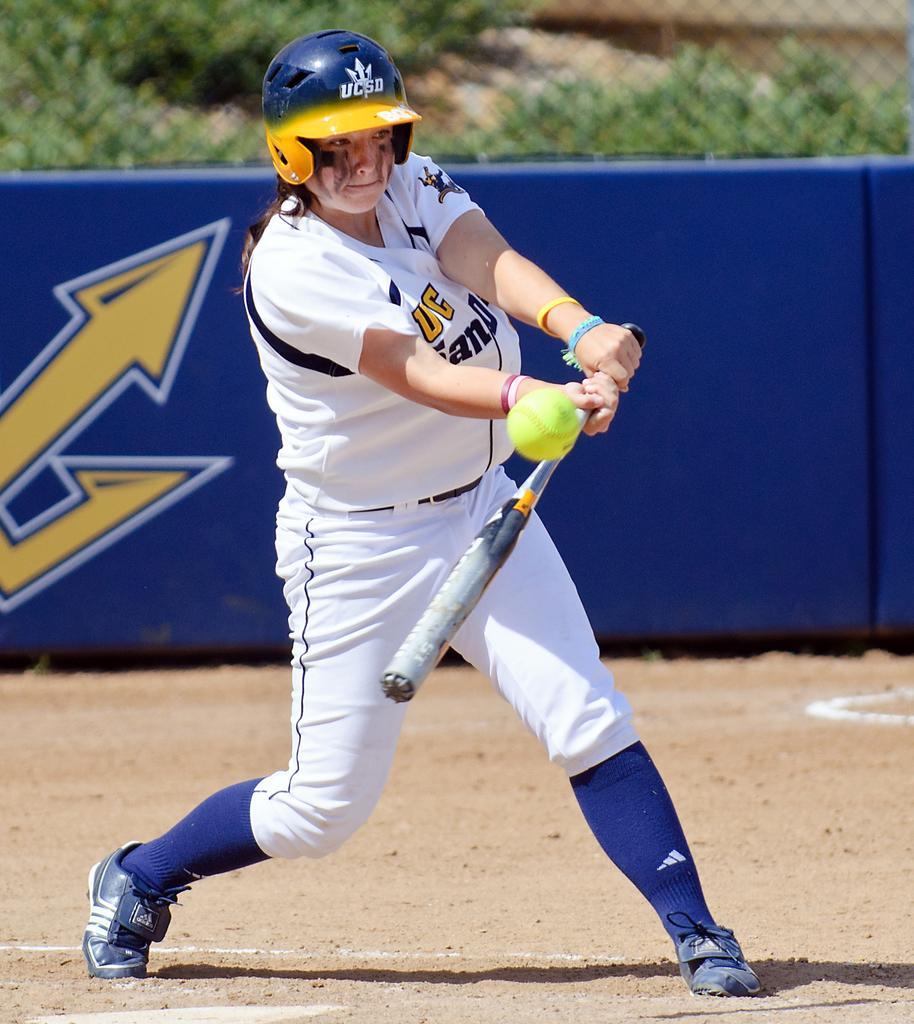Can you describe this image briefly? In the center of the picture there is a woman holding a bat and trying to hit the ball. At the bottom there is soil. In the background there are fencing, banner, outside the fencing there are trees. 